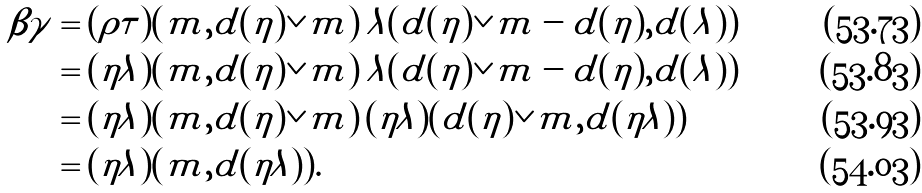Convert formula to latex. <formula><loc_0><loc_0><loc_500><loc_500>\beta \gamma & = ( \rho \tau ) ( m , d ( \eta ) \vee m ) \, \lambda ( d ( \eta ) \vee m - d ( \eta ) , d ( \lambda ) ) \\ & = ( \eta \lambda ) ( m , d ( \eta ) \vee m ) \, \lambda ( d ( \eta ) \vee m - d ( \eta ) , d ( \lambda ) ) \\ & = ( \eta \lambda ) ( m , d ( \eta ) \vee m ) \, ( \eta \lambda ) ( d ( \eta ) \vee m , d ( \eta \lambda ) ) \\ & = ( \eta \lambda ) ( m , d ( \eta \lambda ) ) .</formula> 